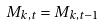<formula> <loc_0><loc_0><loc_500><loc_500>M _ { k , t } = M _ { k , t - 1 }</formula> 